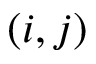<formula> <loc_0><loc_0><loc_500><loc_500>( i , j )</formula> 